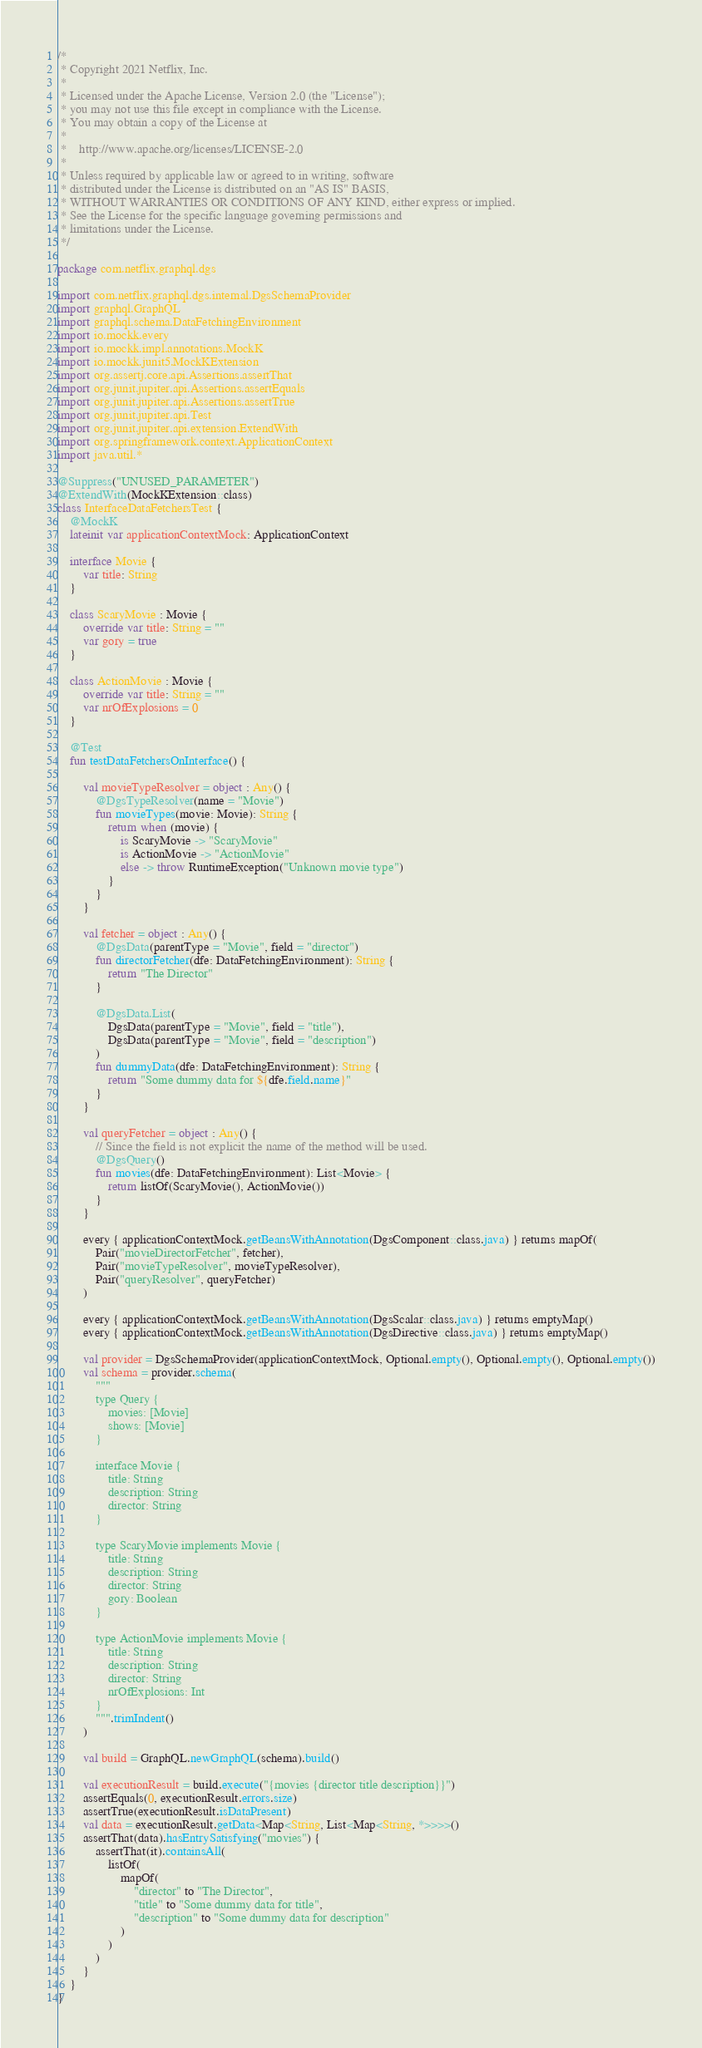Convert code to text. <code><loc_0><loc_0><loc_500><loc_500><_Kotlin_>/*
 * Copyright 2021 Netflix, Inc.
 *
 * Licensed under the Apache License, Version 2.0 (the "License");
 * you may not use this file except in compliance with the License.
 * You may obtain a copy of the License at
 *
 *    http://www.apache.org/licenses/LICENSE-2.0
 *
 * Unless required by applicable law or agreed to in writing, software
 * distributed under the License is distributed on an "AS IS" BASIS,
 * WITHOUT WARRANTIES OR CONDITIONS OF ANY KIND, either express or implied.
 * See the License for the specific language governing permissions and
 * limitations under the License.
 */

package com.netflix.graphql.dgs

import com.netflix.graphql.dgs.internal.DgsSchemaProvider
import graphql.GraphQL
import graphql.schema.DataFetchingEnvironment
import io.mockk.every
import io.mockk.impl.annotations.MockK
import io.mockk.junit5.MockKExtension
import org.assertj.core.api.Assertions.assertThat
import org.junit.jupiter.api.Assertions.assertEquals
import org.junit.jupiter.api.Assertions.assertTrue
import org.junit.jupiter.api.Test
import org.junit.jupiter.api.extension.ExtendWith
import org.springframework.context.ApplicationContext
import java.util.*

@Suppress("UNUSED_PARAMETER")
@ExtendWith(MockKExtension::class)
class InterfaceDataFetchersTest {
    @MockK
    lateinit var applicationContextMock: ApplicationContext

    interface Movie {
        var title: String
    }

    class ScaryMovie : Movie {
        override var title: String = ""
        var gory = true
    }

    class ActionMovie : Movie {
        override var title: String = ""
        var nrOfExplosions = 0
    }

    @Test
    fun testDataFetchersOnInterface() {

        val movieTypeResolver = object : Any() {
            @DgsTypeResolver(name = "Movie")
            fun movieTypes(movie: Movie): String {
                return when (movie) {
                    is ScaryMovie -> "ScaryMovie"
                    is ActionMovie -> "ActionMovie"
                    else -> throw RuntimeException("Unknown movie type")
                }
            }
        }

        val fetcher = object : Any() {
            @DgsData(parentType = "Movie", field = "director")
            fun directorFetcher(dfe: DataFetchingEnvironment): String {
                return "The Director"
            }

            @DgsData.List(
                DgsData(parentType = "Movie", field = "title"),
                DgsData(parentType = "Movie", field = "description")
            )
            fun dummyData(dfe: DataFetchingEnvironment): String {
                return "Some dummy data for ${dfe.field.name}"
            }
        }

        val queryFetcher = object : Any() {
            // Since the field is not explicit the name of the method will be used.
            @DgsQuery()
            fun movies(dfe: DataFetchingEnvironment): List<Movie> {
                return listOf(ScaryMovie(), ActionMovie())
            }
        }

        every { applicationContextMock.getBeansWithAnnotation(DgsComponent::class.java) } returns mapOf(
            Pair("movieDirectorFetcher", fetcher),
            Pair("movieTypeResolver", movieTypeResolver),
            Pair("queryResolver", queryFetcher)
        )

        every { applicationContextMock.getBeansWithAnnotation(DgsScalar::class.java) } returns emptyMap()
        every { applicationContextMock.getBeansWithAnnotation(DgsDirective::class.java) } returns emptyMap()

        val provider = DgsSchemaProvider(applicationContextMock, Optional.empty(), Optional.empty(), Optional.empty())
        val schema = provider.schema(
            """
            type Query {
                movies: [Movie]
                shows: [Movie]
            }
            
            interface Movie {
                title: String
                description: String
                director: String
            }
            
            type ScaryMovie implements Movie {
                title: String
                description: String
                director: String
                gory: Boolean
            }
            
            type ActionMovie implements Movie {
                title: String
                description: String
                director: String
                nrOfExplosions: Int
            }
            """.trimIndent()
        )

        val build = GraphQL.newGraphQL(schema).build()

        val executionResult = build.execute("{movies {director title description}}")
        assertEquals(0, executionResult.errors.size)
        assertTrue(executionResult.isDataPresent)
        val data = executionResult.getData<Map<String, List<Map<String, *>>>>()
        assertThat(data).hasEntrySatisfying("movies") {
            assertThat(it).containsAll(
                listOf(
                    mapOf(
                        "director" to "The Director",
                        "title" to "Some dummy data for title",
                        "description" to "Some dummy data for description"
                    )
                )
            )
        }
    }
}
</code> 